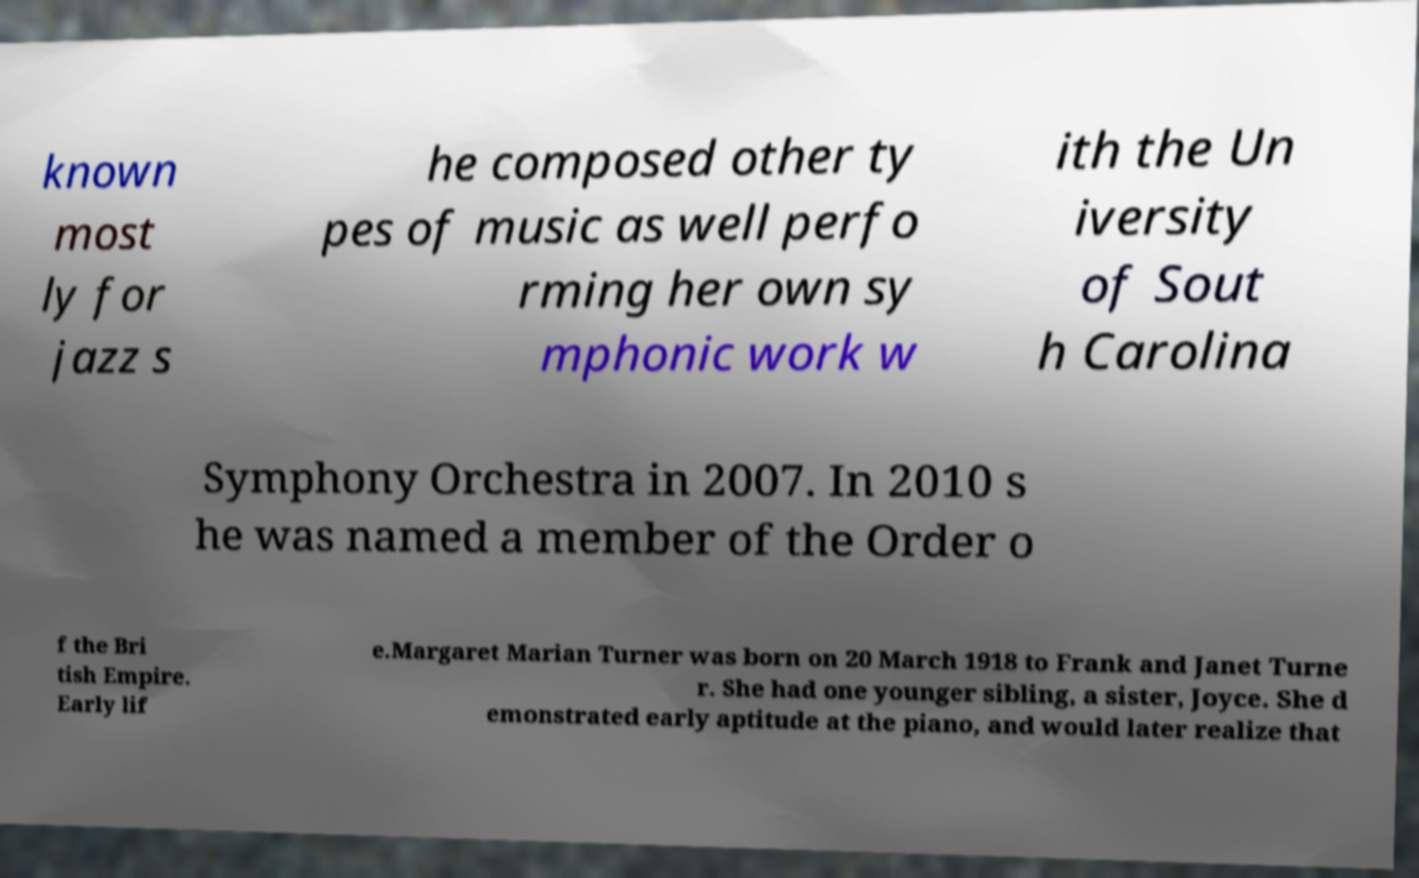There's text embedded in this image that I need extracted. Can you transcribe it verbatim? known most ly for jazz s he composed other ty pes of music as well perfo rming her own sy mphonic work w ith the Un iversity of Sout h Carolina Symphony Orchestra in 2007. In 2010 s he was named a member of the Order o f the Bri tish Empire. Early lif e.Margaret Marian Turner was born on 20 March 1918 to Frank and Janet Turne r. She had one younger sibling, a sister, Joyce. She d emonstrated early aptitude at the piano, and would later realize that 